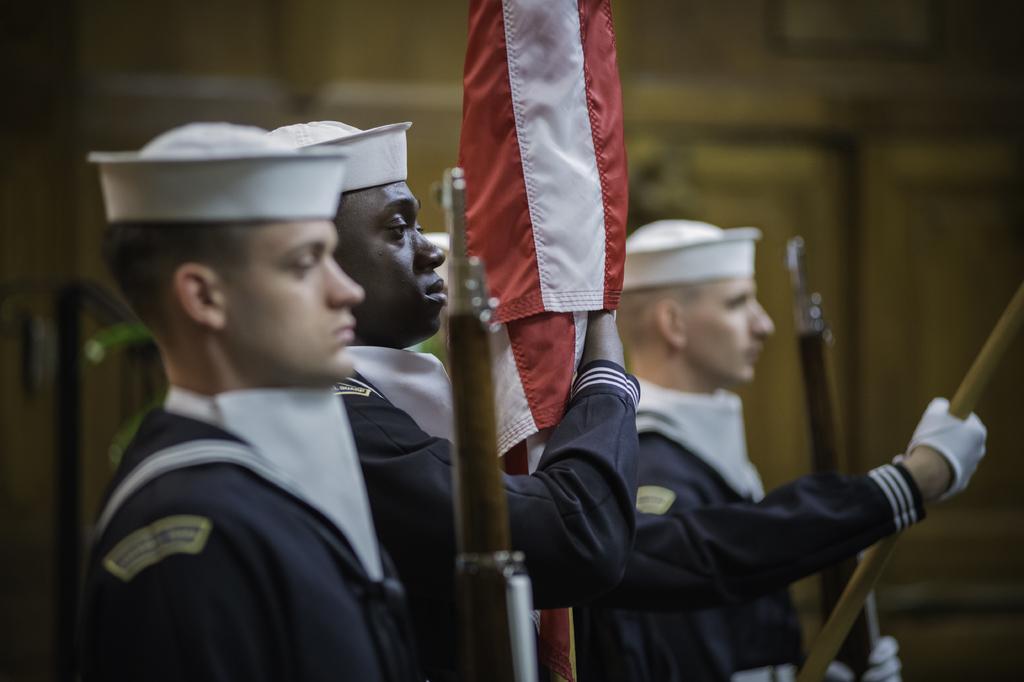Could you give a brief overview of what you see in this image? Here I can see few men wearing uniforms, caps on their heads, holding flags in the hands and facing towards the right side. The background is blurred. 